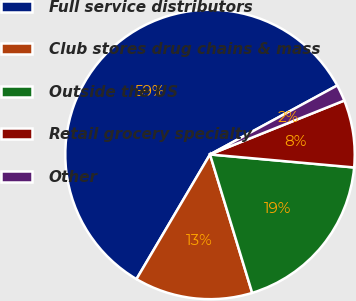Convert chart. <chart><loc_0><loc_0><loc_500><loc_500><pie_chart><fcel>Full service distributors<fcel>Club stores drug chains & mass<fcel>Outside the US<fcel>Retail grocery specialty<fcel>Other<nl><fcel>58.61%<fcel>13.19%<fcel>18.86%<fcel>7.51%<fcel>1.83%<nl></chart> 